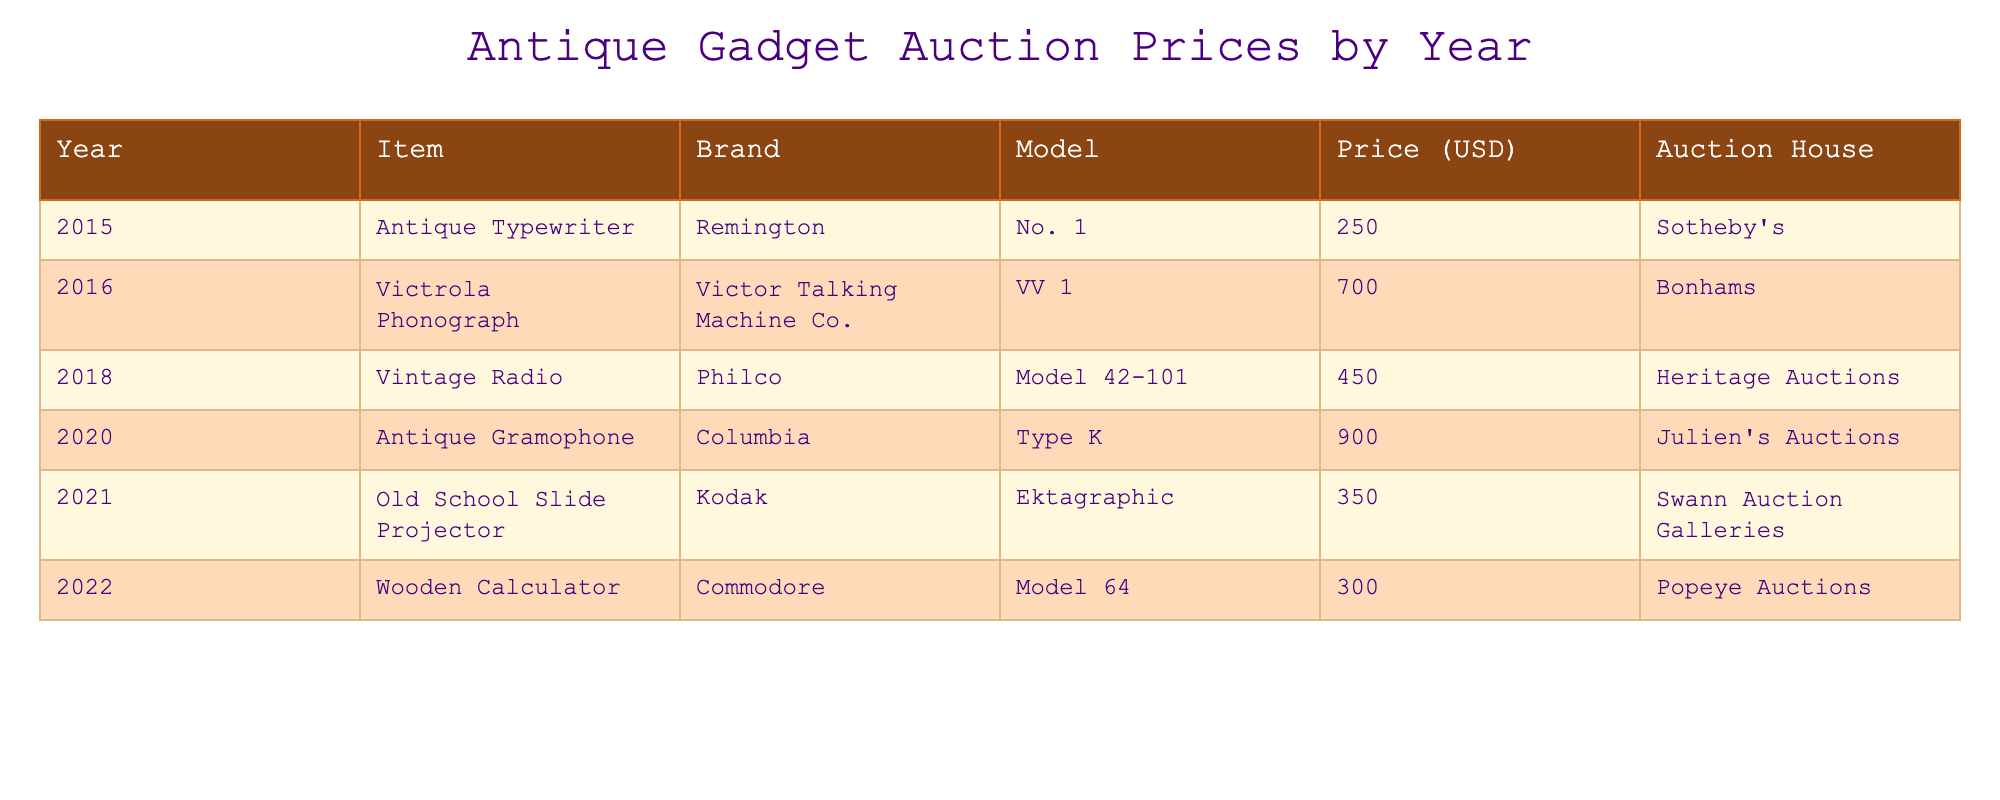What was the highest auction price recorded for an antique gadget? The maximum price is found by reviewing the "Price (USD)" column for each item. The highest price is 1,700.00 for the Victrola Phonograph.
Answer: 1,700.00 Which auction house sold the Antique Gramophone? The auction house associated with the Antique Gramophone is listed in the "Auction House" column for that row, which is Julien's Auctions.
Answer: Julien's Auctions How many items were sold for over 500.00 USD? We can count the rows where the "Price (USD)" exceeds 500.00. The items sold for more than 500.00 are Victrola Phonograph (1,700.00) and Antique Gramophone (900.00), totaling 2 items.
Answer: 2 Is there an Antique Typewriter sold at Sotheby's? By checking the table, we find that there is indeed an Antique Typewriter listed with the auction house Sotheby's. Thus, the answer is yes.
Answer: Yes What is the average auction price of the gadgets listed in the table? To find the average price, we sum all the prices (250.00 + 1,700.00 + 450.00 + 900.00 + 350.00 + 300.00 = 3,950.00). There are 6 items, so we calculate the average as 3,950.00 / 6 = 658.33.
Answer: 658.33 Which years had items sold at auction prices below 400.00 USD? We need to filter the table for auction prices below 400.00 and check the corresponding years. The items below 400.00 USD are the Antique Typewriter (250.00), Old School Slide Projector (350.00), and Wooden Calculator (300.00) sold in the years 2015, 2021, and 2022.
Answer: 2015, 2021, 2022 Which gadget sold for the lowest price? By examining the "Price (USD)" column, the lowest price is for the Antique Typewriter at 250.00 USD.
Answer: 250.00 Did the auction price for the Wooden Calculator exceed that of the Old School Slide Projector? Compare the prices: Wooden Calculator is 300.00 USD and Old School Slide Projector is 350.00 USD. Since 300.00 is less than 350.00, the statement is false.
Answer: No What is the total auction price of gadgets sold between 2015 and 2018? We sum the prices of items sold in those years: Antique Typewriter (250.00), Victrola Phonograph (1,700.00), Vintage Radio (450.00) totaling 2,400.00. Therefore, the total for those years is 2,400.00.
Answer: 2,400.00 